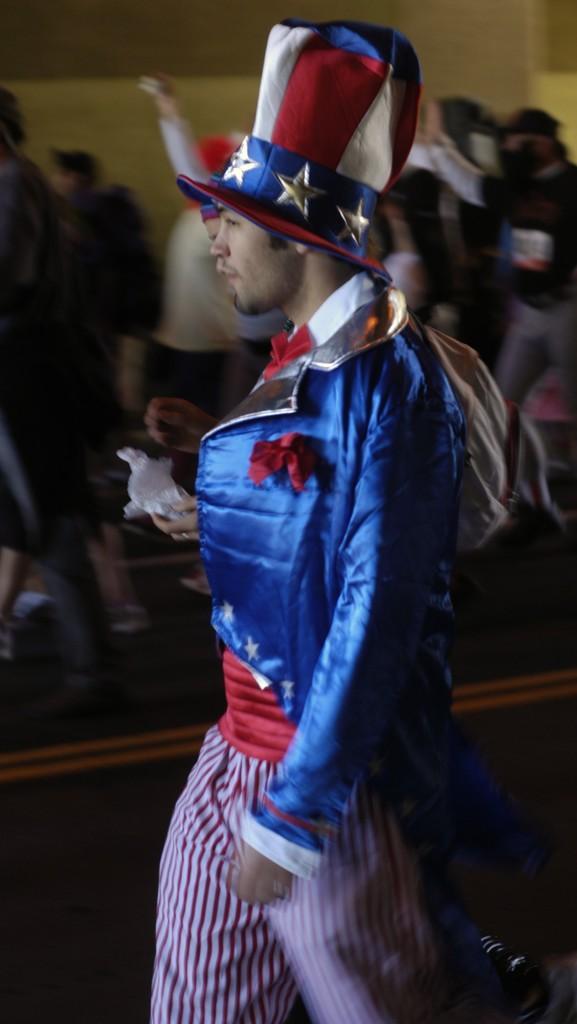In one or two sentences, can you explain what this image depicts? In this picture there are people on the road, among them there's a man wore a cap. In the background of the image it is blurry and we can see wall. 